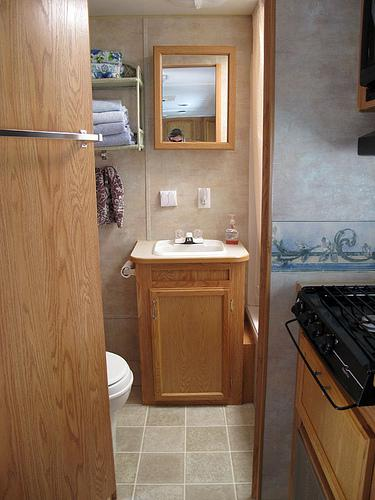Question: how many towels are on the bottom shelf?
Choices:
A. Four.
B. Three.
C. Two.
D. Five.
Answer with the letter. Answer: A Question: what is on the right of the picture outside the bathroom?
Choices:
A. Stove.
B. Table.
C. Fridge.
D. Microwave.
Answer with the letter. Answer: A Question: what type of flooring material is used?
Choices:
A. Wood.
B. Tile.
C. Granite.
D. Linolium.
Answer with the letter. Answer: B Question: where in the house is the picture taken?
Choices:
A. Livingroom.
B. Bedroom.
C. Kitchen.
D. Bathroom.
Answer with the letter. Answer: D 